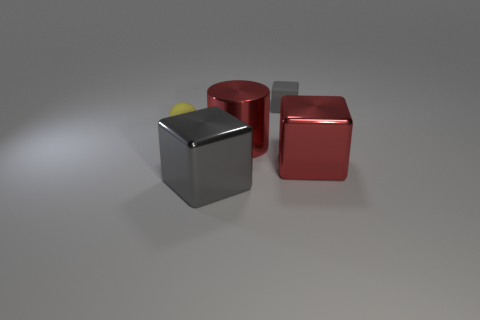The sphere has what color?
Make the answer very short. Yellow. Is the color of the metal object that is on the right side of the tiny gray rubber thing the same as the large cylinder?
Provide a succinct answer. Yes. There is a tiny matte object that is the same shape as the big gray shiny thing; what is its color?
Offer a terse response. Gray. What number of small objects are red metallic cubes or cyan metallic cylinders?
Your response must be concise. 0. There is a thing to the right of the tiny gray rubber thing; how big is it?
Give a very brief answer. Large. Are there any other tiny rubber blocks that have the same color as the matte cube?
Your answer should be very brief. No. What is the shape of the metal object that is the same color as the matte cube?
Keep it short and to the point. Cube. How many cylinders are in front of the gray cube that is behind the tiny yellow matte thing?
Provide a short and direct response. 1. What number of large blocks have the same material as the cylinder?
Ensure brevity in your answer.  2. Are there any rubber objects on the left side of the tiny yellow matte sphere?
Provide a succinct answer. No. 